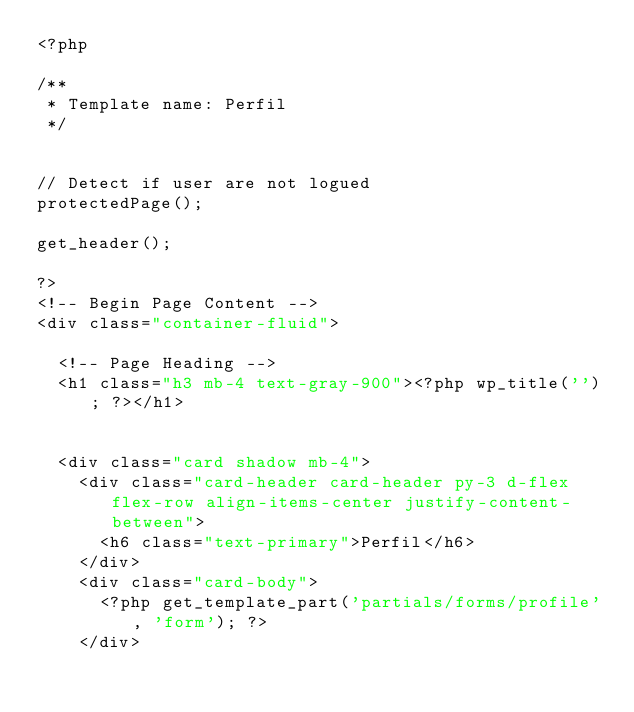Convert code to text. <code><loc_0><loc_0><loc_500><loc_500><_PHP_><?php

/**
 * Template name: Perfil
 */


// Detect if user are not logued
protectedPage();

get_header();

?>
<!-- Begin Page Content -->
<div class="container-fluid">

	<!-- Page Heading -->
	<h1 class="h3 mb-4 text-gray-900"><?php wp_title(''); ?></h1>


	<div class="card shadow mb-4">
		<div class="card-header card-header py-3 d-flex flex-row align-items-center justify-content-between">
			<h6 class="text-primary">Perfil</h6>
		</div>
		<div class="card-body">
			<?php get_template_part('partials/forms/profile', 'form'); ?>
		</div></code> 